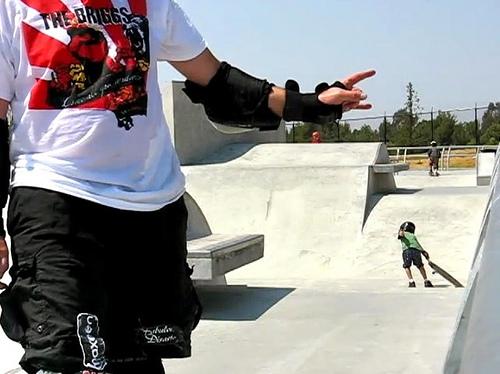IS the man wearing safety gear?
Be succinct. Yes. What color is the man's shirt?
Concise answer only. White. Where is this picture taken?
Keep it brief. Skate park. 